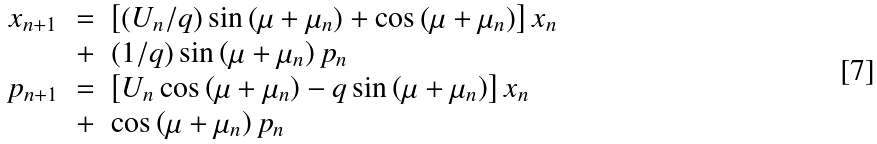<formula> <loc_0><loc_0><loc_500><loc_500>\begin{array} { c c l } x _ { n + 1 } & = & \left [ \left ( U _ { n } / q \right ) \sin \left ( \mu + \mu _ { n } \right ) + \cos \left ( \mu + \mu _ { n } \right ) \right ] x _ { n } \\ & + & ( 1 / q ) \sin \left ( \mu + \mu _ { n } \right ) p _ { n } \\ p _ { n + 1 } & = & \left [ U _ { n } \cos \left ( \mu + \mu _ { n } \right ) - q \sin \left ( \mu + \mu _ { n } \right ) \right ] x _ { n } \\ & + & \cos \left ( \mu + \mu _ { n } \right ) p _ { n } \\ \end{array}</formula> 